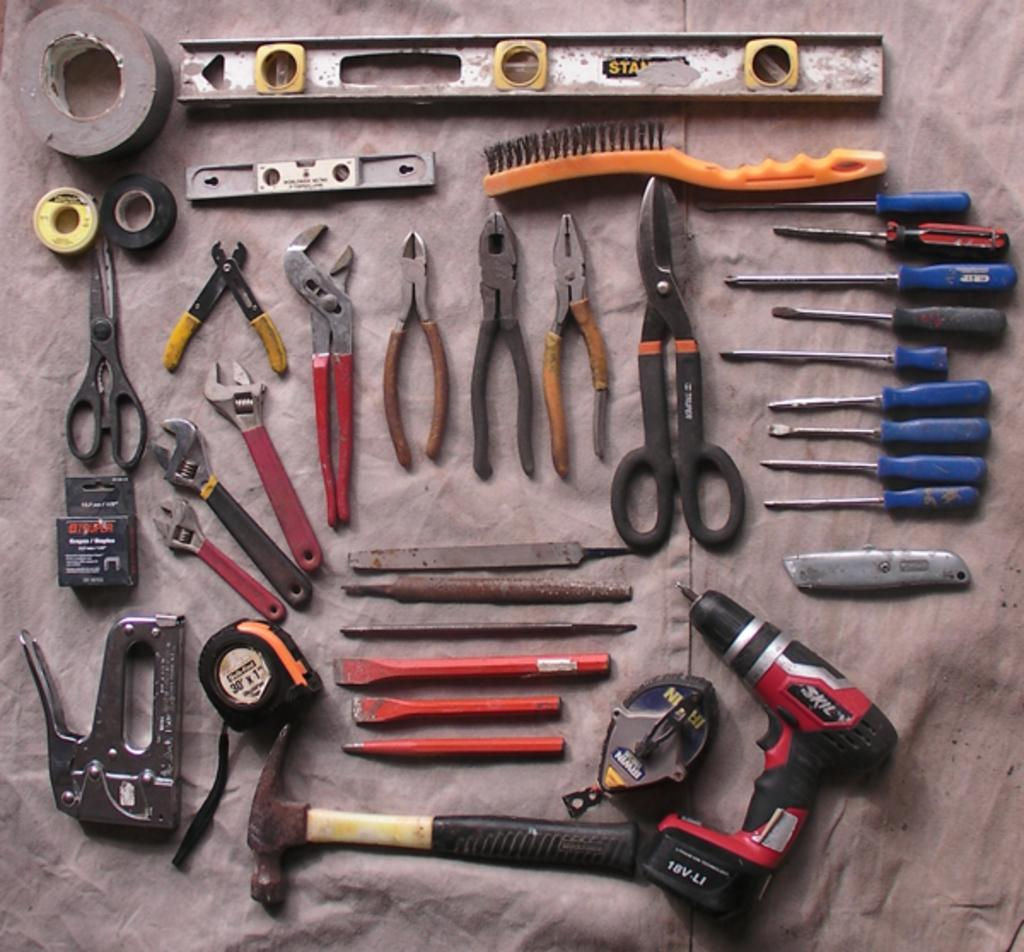What objects can be seen in the image? There are tools in the image. Can you describe the tools in more detail? Unfortunately, the provided facts do not give any specific details about the tools. Are the tools being used for a particular purpose in the image? The provided facts do not give any information about the purpose or use of the tools. What type of bottle is being used to form the tools in the image? There is no bottle or form-making process depicted in the image; it only shows tools. 